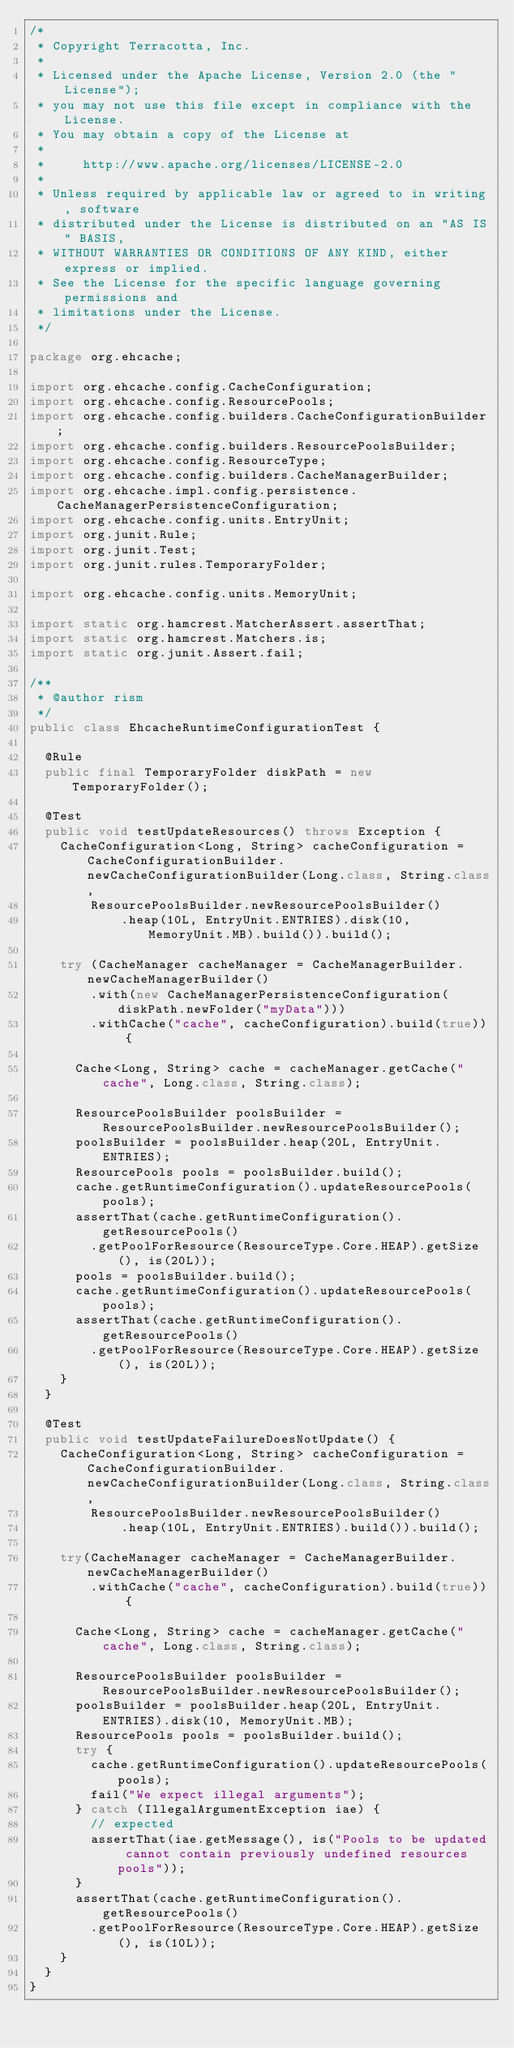Convert code to text. <code><loc_0><loc_0><loc_500><loc_500><_Java_>/*
 * Copyright Terracotta, Inc.
 *
 * Licensed under the Apache License, Version 2.0 (the "License");
 * you may not use this file except in compliance with the License.
 * You may obtain a copy of the License at
 *
 *     http://www.apache.org/licenses/LICENSE-2.0
 *
 * Unless required by applicable law or agreed to in writing, software
 * distributed under the License is distributed on an "AS IS" BASIS,
 * WITHOUT WARRANTIES OR CONDITIONS OF ANY KIND, either express or implied.
 * See the License for the specific language governing permissions and
 * limitations under the License.
 */

package org.ehcache;

import org.ehcache.config.CacheConfiguration;
import org.ehcache.config.ResourcePools;
import org.ehcache.config.builders.CacheConfigurationBuilder;
import org.ehcache.config.builders.ResourcePoolsBuilder;
import org.ehcache.config.ResourceType;
import org.ehcache.config.builders.CacheManagerBuilder;
import org.ehcache.impl.config.persistence.CacheManagerPersistenceConfiguration;
import org.ehcache.config.units.EntryUnit;
import org.junit.Rule;
import org.junit.Test;
import org.junit.rules.TemporaryFolder;

import org.ehcache.config.units.MemoryUnit;

import static org.hamcrest.MatcherAssert.assertThat;
import static org.hamcrest.Matchers.is;
import static org.junit.Assert.fail;

/**
 * @author rism
 */
public class EhcacheRuntimeConfigurationTest {

  @Rule
  public final TemporaryFolder diskPath = new TemporaryFolder();

  @Test
  public void testUpdateResources() throws Exception {
    CacheConfiguration<Long, String> cacheConfiguration = CacheConfigurationBuilder.newCacheConfigurationBuilder(Long.class, String.class,
        ResourcePoolsBuilder.newResourcePoolsBuilder()
            .heap(10L, EntryUnit.ENTRIES).disk(10, MemoryUnit.MB).build()).build();

    try (CacheManager cacheManager = CacheManagerBuilder.newCacheManagerBuilder()
        .with(new CacheManagerPersistenceConfiguration(diskPath.newFolder("myData")))
        .withCache("cache", cacheConfiguration).build(true)) {

      Cache<Long, String> cache = cacheManager.getCache("cache", Long.class, String.class);

      ResourcePoolsBuilder poolsBuilder = ResourcePoolsBuilder.newResourcePoolsBuilder();
      poolsBuilder = poolsBuilder.heap(20L, EntryUnit.ENTRIES);
      ResourcePools pools = poolsBuilder.build();
      cache.getRuntimeConfiguration().updateResourcePools(pools);
      assertThat(cache.getRuntimeConfiguration().getResourcePools()
        .getPoolForResource(ResourceType.Core.HEAP).getSize(), is(20L));
      pools = poolsBuilder.build();
      cache.getRuntimeConfiguration().updateResourcePools(pools);
      assertThat(cache.getRuntimeConfiguration().getResourcePools()
        .getPoolForResource(ResourceType.Core.HEAP).getSize(), is(20L));
    }
  }

  @Test
  public void testUpdateFailureDoesNotUpdate() {
    CacheConfiguration<Long, String> cacheConfiguration = CacheConfigurationBuilder.newCacheConfigurationBuilder(Long.class, String.class,
        ResourcePoolsBuilder.newResourcePoolsBuilder()
            .heap(10L, EntryUnit.ENTRIES).build()).build();

    try(CacheManager cacheManager = CacheManagerBuilder.newCacheManagerBuilder()
        .withCache("cache", cacheConfiguration).build(true)) {

      Cache<Long, String> cache = cacheManager.getCache("cache", Long.class, String.class);

      ResourcePoolsBuilder poolsBuilder = ResourcePoolsBuilder.newResourcePoolsBuilder();
      poolsBuilder = poolsBuilder.heap(20L, EntryUnit.ENTRIES).disk(10, MemoryUnit.MB);
      ResourcePools pools = poolsBuilder.build();
      try {
        cache.getRuntimeConfiguration().updateResourcePools(pools);
        fail("We expect illegal arguments");
      } catch (IllegalArgumentException iae) {
        // expected
        assertThat(iae.getMessage(), is("Pools to be updated cannot contain previously undefined resources pools"));
      }
      assertThat(cache.getRuntimeConfiguration().getResourcePools()
        .getPoolForResource(ResourceType.Core.HEAP).getSize(), is(10L));
    }
  }
}
</code> 